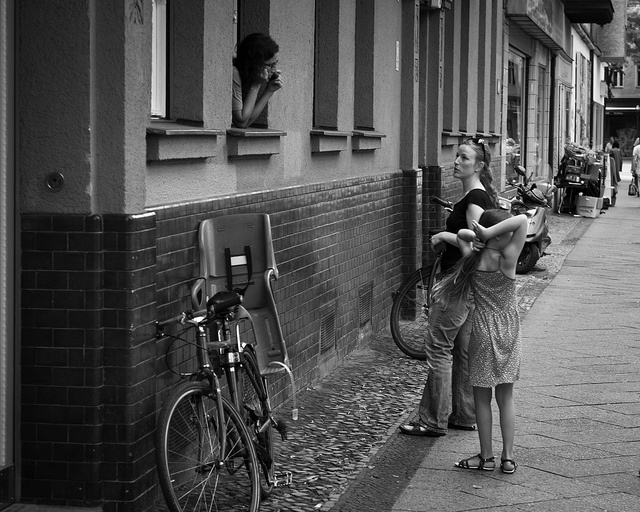Describe the objects in this image and their specific colors. I can see bicycle in black, gray, darkgray, and lightgray tones, people in black, gray, darkgray, and lightgray tones, people in black, gray, darkgray, and lightgray tones, people in black, gray, and lightgray tones, and bicycle in black, gray, and lightgray tones in this image. 